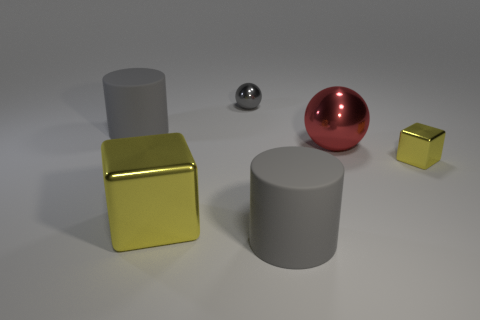Add 2 small gray shiny cylinders. How many objects exist? 8 Subtract all cubes. How many objects are left? 4 Add 5 tiny objects. How many tiny objects are left? 7 Add 5 gray objects. How many gray objects exist? 8 Subtract 2 gray cylinders. How many objects are left? 4 Subtract all tiny things. Subtract all shiny balls. How many objects are left? 2 